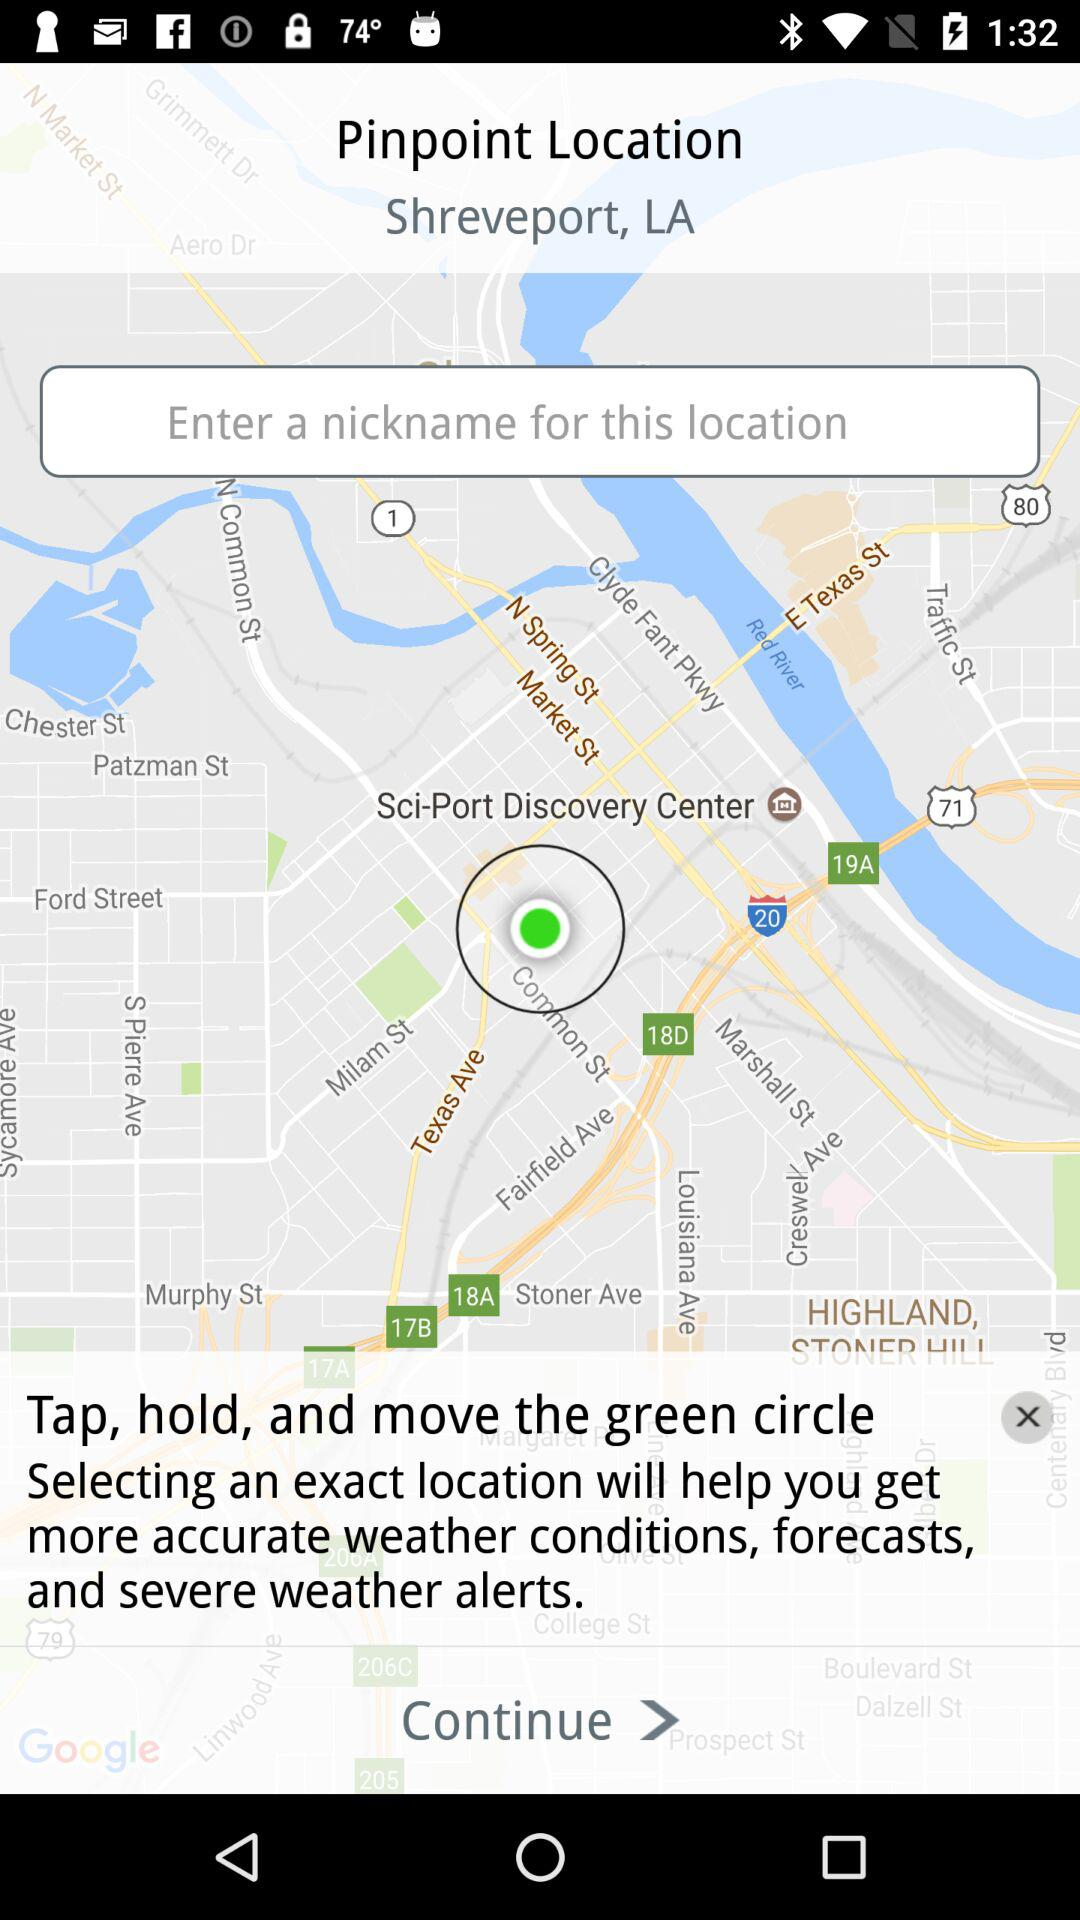What is the pinpoint location? The pinpoint location is Shreveport, LA. 